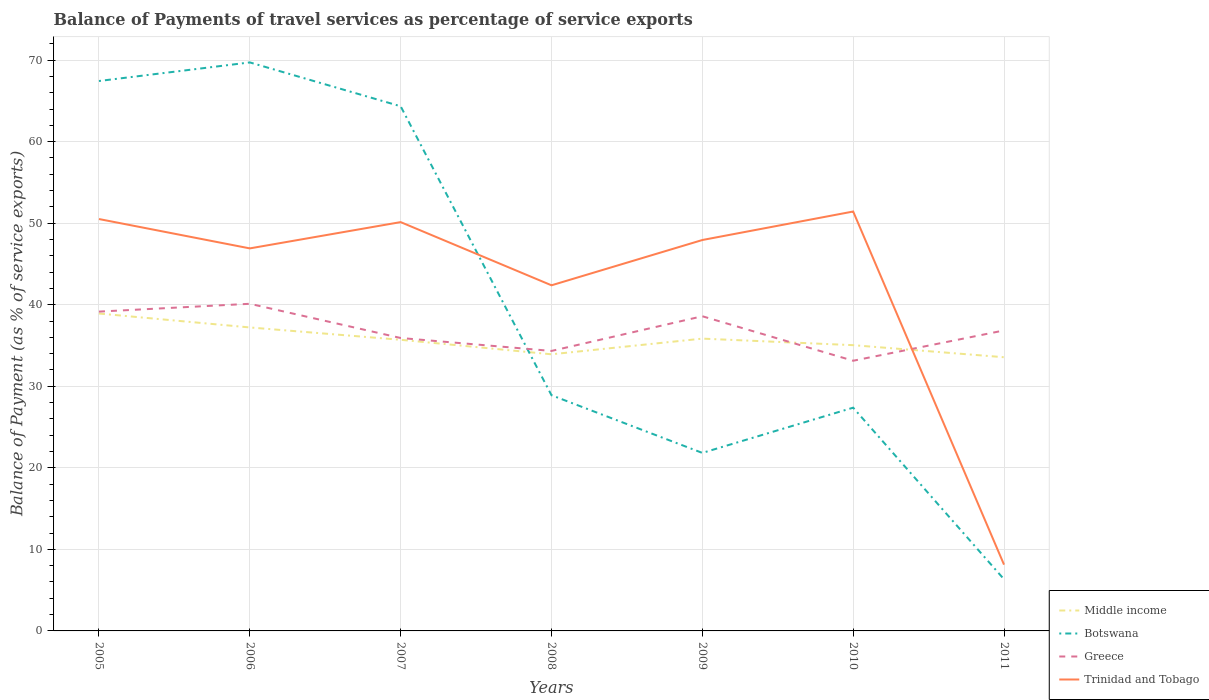Across all years, what is the maximum balance of payments of travel services in Middle income?
Your answer should be compact. 33.56. In which year was the balance of payments of travel services in Middle income maximum?
Keep it short and to the point. 2011. What is the total balance of payments of travel services in Middle income in the graph?
Offer a terse response. 3.08. What is the difference between the highest and the second highest balance of payments of travel services in Trinidad and Tobago?
Make the answer very short. 43.3. What is the difference between the highest and the lowest balance of payments of travel services in Trinidad and Tobago?
Provide a short and direct response. 5. How many lines are there?
Provide a succinct answer. 4. Does the graph contain grids?
Your response must be concise. Yes. How are the legend labels stacked?
Your answer should be very brief. Vertical. What is the title of the graph?
Offer a terse response. Balance of Payments of travel services as percentage of service exports. Does "Somalia" appear as one of the legend labels in the graph?
Give a very brief answer. No. What is the label or title of the X-axis?
Offer a very short reply. Years. What is the label or title of the Y-axis?
Give a very brief answer. Balance of Payment (as % of service exports). What is the Balance of Payment (as % of service exports) of Middle income in 2005?
Offer a very short reply. 38.92. What is the Balance of Payment (as % of service exports) in Botswana in 2005?
Give a very brief answer. 67.43. What is the Balance of Payment (as % of service exports) in Greece in 2005?
Offer a terse response. 39.16. What is the Balance of Payment (as % of service exports) of Trinidad and Tobago in 2005?
Give a very brief answer. 50.51. What is the Balance of Payment (as % of service exports) of Middle income in 2006?
Your answer should be compact. 37.21. What is the Balance of Payment (as % of service exports) in Botswana in 2006?
Provide a succinct answer. 69.71. What is the Balance of Payment (as % of service exports) of Greece in 2006?
Keep it short and to the point. 40.11. What is the Balance of Payment (as % of service exports) of Trinidad and Tobago in 2006?
Ensure brevity in your answer.  46.91. What is the Balance of Payment (as % of service exports) of Middle income in 2007?
Ensure brevity in your answer.  35.7. What is the Balance of Payment (as % of service exports) in Botswana in 2007?
Offer a terse response. 64.33. What is the Balance of Payment (as % of service exports) of Greece in 2007?
Keep it short and to the point. 35.92. What is the Balance of Payment (as % of service exports) in Trinidad and Tobago in 2007?
Offer a very short reply. 50.13. What is the Balance of Payment (as % of service exports) of Middle income in 2008?
Provide a short and direct response. 33.92. What is the Balance of Payment (as % of service exports) in Botswana in 2008?
Your answer should be compact. 28.9. What is the Balance of Payment (as % of service exports) of Greece in 2008?
Provide a succinct answer. 34.33. What is the Balance of Payment (as % of service exports) in Trinidad and Tobago in 2008?
Provide a short and direct response. 42.38. What is the Balance of Payment (as % of service exports) of Middle income in 2009?
Offer a very short reply. 35.84. What is the Balance of Payment (as % of service exports) of Botswana in 2009?
Your answer should be compact. 21.83. What is the Balance of Payment (as % of service exports) of Greece in 2009?
Provide a succinct answer. 38.59. What is the Balance of Payment (as % of service exports) in Trinidad and Tobago in 2009?
Offer a very short reply. 47.93. What is the Balance of Payment (as % of service exports) of Middle income in 2010?
Offer a very short reply. 35.04. What is the Balance of Payment (as % of service exports) of Botswana in 2010?
Provide a succinct answer. 27.38. What is the Balance of Payment (as % of service exports) of Greece in 2010?
Give a very brief answer. 33.13. What is the Balance of Payment (as % of service exports) of Trinidad and Tobago in 2010?
Make the answer very short. 51.43. What is the Balance of Payment (as % of service exports) of Middle income in 2011?
Offer a terse response. 33.56. What is the Balance of Payment (as % of service exports) of Botswana in 2011?
Your answer should be very brief. 6.33. What is the Balance of Payment (as % of service exports) of Greece in 2011?
Keep it short and to the point. 36.85. What is the Balance of Payment (as % of service exports) in Trinidad and Tobago in 2011?
Give a very brief answer. 8.13. Across all years, what is the maximum Balance of Payment (as % of service exports) of Middle income?
Keep it short and to the point. 38.92. Across all years, what is the maximum Balance of Payment (as % of service exports) of Botswana?
Give a very brief answer. 69.71. Across all years, what is the maximum Balance of Payment (as % of service exports) of Greece?
Your answer should be compact. 40.11. Across all years, what is the maximum Balance of Payment (as % of service exports) of Trinidad and Tobago?
Provide a short and direct response. 51.43. Across all years, what is the minimum Balance of Payment (as % of service exports) of Middle income?
Ensure brevity in your answer.  33.56. Across all years, what is the minimum Balance of Payment (as % of service exports) in Botswana?
Give a very brief answer. 6.33. Across all years, what is the minimum Balance of Payment (as % of service exports) in Greece?
Offer a terse response. 33.13. Across all years, what is the minimum Balance of Payment (as % of service exports) of Trinidad and Tobago?
Your response must be concise. 8.13. What is the total Balance of Payment (as % of service exports) of Middle income in the graph?
Provide a short and direct response. 250.2. What is the total Balance of Payment (as % of service exports) in Botswana in the graph?
Provide a succinct answer. 285.92. What is the total Balance of Payment (as % of service exports) of Greece in the graph?
Keep it short and to the point. 258.09. What is the total Balance of Payment (as % of service exports) of Trinidad and Tobago in the graph?
Offer a terse response. 297.42. What is the difference between the Balance of Payment (as % of service exports) of Middle income in 2005 and that in 2006?
Provide a short and direct response. 1.71. What is the difference between the Balance of Payment (as % of service exports) of Botswana in 2005 and that in 2006?
Make the answer very short. -2.28. What is the difference between the Balance of Payment (as % of service exports) in Greece in 2005 and that in 2006?
Provide a succinct answer. -0.96. What is the difference between the Balance of Payment (as % of service exports) in Trinidad and Tobago in 2005 and that in 2006?
Your answer should be compact. 3.6. What is the difference between the Balance of Payment (as % of service exports) of Middle income in 2005 and that in 2007?
Give a very brief answer. 3.22. What is the difference between the Balance of Payment (as % of service exports) of Botswana in 2005 and that in 2007?
Give a very brief answer. 3.1. What is the difference between the Balance of Payment (as % of service exports) of Greece in 2005 and that in 2007?
Your answer should be compact. 3.23. What is the difference between the Balance of Payment (as % of service exports) in Trinidad and Tobago in 2005 and that in 2007?
Provide a succinct answer. 0.38. What is the difference between the Balance of Payment (as % of service exports) of Middle income in 2005 and that in 2008?
Keep it short and to the point. 5. What is the difference between the Balance of Payment (as % of service exports) of Botswana in 2005 and that in 2008?
Keep it short and to the point. 38.53. What is the difference between the Balance of Payment (as % of service exports) in Greece in 2005 and that in 2008?
Ensure brevity in your answer.  4.82. What is the difference between the Balance of Payment (as % of service exports) in Trinidad and Tobago in 2005 and that in 2008?
Your answer should be compact. 8.13. What is the difference between the Balance of Payment (as % of service exports) in Middle income in 2005 and that in 2009?
Offer a terse response. 3.08. What is the difference between the Balance of Payment (as % of service exports) of Botswana in 2005 and that in 2009?
Ensure brevity in your answer.  45.6. What is the difference between the Balance of Payment (as % of service exports) of Greece in 2005 and that in 2009?
Keep it short and to the point. 0.57. What is the difference between the Balance of Payment (as % of service exports) of Trinidad and Tobago in 2005 and that in 2009?
Provide a short and direct response. 2.57. What is the difference between the Balance of Payment (as % of service exports) in Middle income in 2005 and that in 2010?
Give a very brief answer. 3.88. What is the difference between the Balance of Payment (as % of service exports) in Botswana in 2005 and that in 2010?
Offer a terse response. 40.06. What is the difference between the Balance of Payment (as % of service exports) in Greece in 2005 and that in 2010?
Keep it short and to the point. 6.02. What is the difference between the Balance of Payment (as % of service exports) of Trinidad and Tobago in 2005 and that in 2010?
Offer a terse response. -0.92. What is the difference between the Balance of Payment (as % of service exports) of Middle income in 2005 and that in 2011?
Provide a succinct answer. 5.36. What is the difference between the Balance of Payment (as % of service exports) of Botswana in 2005 and that in 2011?
Keep it short and to the point. 61.1. What is the difference between the Balance of Payment (as % of service exports) of Greece in 2005 and that in 2011?
Keep it short and to the point. 2.31. What is the difference between the Balance of Payment (as % of service exports) of Trinidad and Tobago in 2005 and that in 2011?
Provide a succinct answer. 42.38. What is the difference between the Balance of Payment (as % of service exports) of Middle income in 2006 and that in 2007?
Provide a succinct answer. 1.51. What is the difference between the Balance of Payment (as % of service exports) in Botswana in 2006 and that in 2007?
Ensure brevity in your answer.  5.38. What is the difference between the Balance of Payment (as % of service exports) of Greece in 2006 and that in 2007?
Make the answer very short. 4.19. What is the difference between the Balance of Payment (as % of service exports) in Trinidad and Tobago in 2006 and that in 2007?
Give a very brief answer. -3.22. What is the difference between the Balance of Payment (as % of service exports) in Middle income in 2006 and that in 2008?
Keep it short and to the point. 3.29. What is the difference between the Balance of Payment (as % of service exports) in Botswana in 2006 and that in 2008?
Ensure brevity in your answer.  40.81. What is the difference between the Balance of Payment (as % of service exports) of Greece in 2006 and that in 2008?
Ensure brevity in your answer.  5.78. What is the difference between the Balance of Payment (as % of service exports) in Trinidad and Tobago in 2006 and that in 2008?
Provide a short and direct response. 4.53. What is the difference between the Balance of Payment (as % of service exports) of Middle income in 2006 and that in 2009?
Your response must be concise. 1.37. What is the difference between the Balance of Payment (as % of service exports) of Botswana in 2006 and that in 2009?
Your answer should be very brief. 47.88. What is the difference between the Balance of Payment (as % of service exports) of Greece in 2006 and that in 2009?
Provide a short and direct response. 1.53. What is the difference between the Balance of Payment (as % of service exports) of Trinidad and Tobago in 2006 and that in 2009?
Your answer should be compact. -1.03. What is the difference between the Balance of Payment (as % of service exports) of Middle income in 2006 and that in 2010?
Your answer should be compact. 2.17. What is the difference between the Balance of Payment (as % of service exports) of Botswana in 2006 and that in 2010?
Provide a short and direct response. 42.34. What is the difference between the Balance of Payment (as % of service exports) in Greece in 2006 and that in 2010?
Ensure brevity in your answer.  6.98. What is the difference between the Balance of Payment (as % of service exports) of Trinidad and Tobago in 2006 and that in 2010?
Your answer should be very brief. -4.52. What is the difference between the Balance of Payment (as % of service exports) of Middle income in 2006 and that in 2011?
Make the answer very short. 3.65. What is the difference between the Balance of Payment (as % of service exports) of Botswana in 2006 and that in 2011?
Ensure brevity in your answer.  63.38. What is the difference between the Balance of Payment (as % of service exports) of Greece in 2006 and that in 2011?
Your answer should be very brief. 3.27. What is the difference between the Balance of Payment (as % of service exports) of Trinidad and Tobago in 2006 and that in 2011?
Give a very brief answer. 38.78. What is the difference between the Balance of Payment (as % of service exports) in Middle income in 2007 and that in 2008?
Make the answer very short. 1.78. What is the difference between the Balance of Payment (as % of service exports) of Botswana in 2007 and that in 2008?
Give a very brief answer. 35.43. What is the difference between the Balance of Payment (as % of service exports) in Greece in 2007 and that in 2008?
Your answer should be compact. 1.59. What is the difference between the Balance of Payment (as % of service exports) in Trinidad and Tobago in 2007 and that in 2008?
Your response must be concise. 7.75. What is the difference between the Balance of Payment (as % of service exports) in Middle income in 2007 and that in 2009?
Give a very brief answer. -0.14. What is the difference between the Balance of Payment (as % of service exports) in Botswana in 2007 and that in 2009?
Offer a terse response. 42.5. What is the difference between the Balance of Payment (as % of service exports) of Greece in 2007 and that in 2009?
Make the answer very short. -2.67. What is the difference between the Balance of Payment (as % of service exports) of Trinidad and Tobago in 2007 and that in 2009?
Give a very brief answer. 2.2. What is the difference between the Balance of Payment (as % of service exports) in Middle income in 2007 and that in 2010?
Provide a short and direct response. 0.66. What is the difference between the Balance of Payment (as % of service exports) of Botswana in 2007 and that in 2010?
Offer a terse response. 36.96. What is the difference between the Balance of Payment (as % of service exports) in Greece in 2007 and that in 2010?
Keep it short and to the point. 2.79. What is the difference between the Balance of Payment (as % of service exports) in Trinidad and Tobago in 2007 and that in 2010?
Your answer should be very brief. -1.3. What is the difference between the Balance of Payment (as % of service exports) of Middle income in 2007 and that in 2011?
Your response must be concise. 2.14. What is the difference between the Balance of Payment (as % of service exports) of Greece in 2007 and that in 2011?
Give a very brief answer. -0.93. What is the difference between the Balance of Payment (as % of service exports) of Trinidad and Tobago in 2007 and that in 2011?
Give a very brief answer. 42. What is the difference between the Balance of Payment (as % of service exports) in Middle income in 2008 and that in 2009?
Give a very brief answer. -1.92. What is the difference between the Balance of Payment (as % of service exports) in Botswana in 2008 and that in 2009?
Provide a short and direct response. 7.07. What is the difference between the Balance of Payment (as % of service exports) in Greece in 2008 and that in 2009?
Your answer should be compact. -4.25. What is the difference between the Balance of Payment (as % of service exports) in Trinidad and Tobago in 2008 and that in 2009?
Your answer should be very brief. -5.55. What is the difference between the Balance of Payment (as % of service exports) in Middle income in 2008 and that in 2010?
Provide a succinct answer. -1.12. What is the difference between the Balance of Payment (as % of service exports) of Botswana in 2008 and that in 2010?
Your response must be concise. 1.53. What is the difference between the Balance of Payment (as % of service exports) in Greece in 2008 and that in 2010?
Offer a very short reply. 1.2. What is the difference between the Balance of Payment (as % of service exports) in Trinidad and Tobago in 2008 and that in 2010?
Your answer should be compact. -9.05. What is the difference between the Balance of Payment (as % of service exports) of Middle income in 2008 and that in 2011?
Provide a short and direct response. 0.36. What is the difference between the Balance of Payment (as % of service exports) in Botswana in 2008 and that in 2011?
Offer a terse response. 22.57. What is the difference between the Balance of Payment (as % of service exports) in Greece in 2008 and that in 2011?
Ensure brevity in your answer.  -2.51. What is the difference between the Balance of Payment (as % of service exports) of Trinidad and Tobago in 2008 and that in 2011?
Provide a short and direct response. 34.25. What is the difference between the Balance of Payment (as % of service exports) of Middle income in 2009 and that in 2010?
Offer a terse response. 0.8. What is the difference between the Balance of Payment (as % of service exports) of Botswana in 2009 and that in 2010?
Your answer should be very brief. -5.55. What is the difference between the Balance of Payment (as % of service exports) of Greece in 2009 and that in 2010?
Offer a very short reply. 5.46. What is the difference between the Balance of Payment (as % of service exports) of Trinidad and Tobago in 2009 and that in 2010?
Keep it short and to the point. -3.5. What is the difference between the Balance of Payment (as % of service exports) of Middle income in 2009 and that in 2011?
Your answer should be compact. 2.28. What is the difference between the Balance of Payment (as % of service exports) of Botswana in 2009 and that in 2011?
Provide a short and direct response. 15.5. What is the difference between the Balance of Payment (as % of service exports) in Greece in 2009 and that in 2011?
Make the answer very short. 1.74. What is the difference between the Balance of Payment (as % of service exports) in Trinidad and Tobago in 2009 and that in 2011?
Give a very brief answer. 39.81. What is the difference between the Balance of Payment (as % of service exports) in Middle income in 2010 and that in 2011?
Your response must be concise. 1.48. What is the difference between the Balance of Payment (as % of service exports) of Botswana in 2010 and that in 2011?
Your answer should be very brief. 21.04. What is the difference between the Balance of Payment (as % of service exports) in Greece in 2010 and that in 2011?
Provide a succinct answer. -3.72. What is the difference between the Balance of Payment (as % of service exports) in Trinidad and Tobago in 2010 and that in 2011?
Give a very brief answer. 43.3. What is the difference between the Balance of Payment (as % of service exports) of Middle income in 2005 and the Balance of Payment (as % of service exports) of Botswana in 2006?
Make the answer very short. -30.79. What is the difference between the Balance of Payment (as % of service exports) of Middle income in 2005 and the Balance of Payment (as % of service exports) of Greece in 2006?
Your answer should be very brief. -1.19. What is the difference between the Balance of Payment (as % of service exports) of Middle income in 2005 and the Balance of Payment (as % of service exports) of Trinidad and Tobago in 2006?
Your response must be concise. -7.99. What is the difference between the Balance of Payment (as % of service exports) in Botswana in 2005 and the Balance of Payment (as % of service exports) in Greece in 2006?
Offer a very short reply. 27.32. What is the difference between the Balance of Payment (as % of service exports) of Botswana in 2005 and the Balance of Payment (as % of service exports) of Trinidad and Tobago in 2006?
Your response must be concise. 20.52. What is the difference between the Balance of Payment (as % of service exports) of Greece in 2005 and the Balance of Payment (as % of service exports) of Trinidad and Tobago in 2006?
Provide a short and direct response. -7.75. What is the difference between the Balance of Payment (as % of service exports) of Middle income in 2005 and the Balance of Payment (as % of service exports) of Botswana in 2007?
Ensure brevity in your answer.  -25.41. What is the difference between the Balance of Payment (as % of service exports) of Middle income in 2005 and the Balance of Payment (as % of service exports) of Greece in 2007?
Keep it short and to the point. 3. What is the difference between the Balance of Payment (as % of service exports) of Middle income in 2005 and the Balance of Payment (as % of service exports) of Trinidad and Tobago in 2007?
Ensure brevity in your answer.  -11.21. What is the difference between the Balance of Payment (as % of service exports) of Botswana in 2005 and the Balance of Payment (as % of service exports) of Greece in 2007?
Provide a succinct answer. 31.51. What is the difference between the Balance of Payment (as % of service exports) in Botswana in 2005 and the Balance of Payment (as % of service exports) in Trinidad and Tobago in 2007?
Offer a very short reply. 17.3. What is the difference between the Balance of Payment (as % of service exports) of Greece in 2005 and the Balance of Payment (as % of service exports) of Trinidad and Tobago in 2007?
Your answer should be compact. -10.97. What is the difference between the Balance of Payment (as % of service exports) of Middle income in 2005 and the Balance of Payment (as % of service exports) of Botswana in 2008?
Your response must be concise. 10.02. What is the difference between the Balance of Payment (as % of service exports) of Middle income in 2005 and the Balance of Payment (as % of service exports) of Greece in 2008?
Provide a succinct answer. 4.59. What is the difference between the Balance of Payment (as % of service exports) of Middle income in 2005 and the Balance of Payment (as % of service exports) of Trinidad and Tobago in 2008?
Ensure brevity in your answer.  -3.46. What is the difference between the Balance of Payment (as % of service exports) of Botswana in 2005 and the Balance of Payment (as % of service exports) of Greece in 2008?
Keep it short and to the point. 33.1. What is the difference between the Balance of Payment (as % of service exports) in Botswana in 2005 and the Balance of Payment (as % of service exports) in Trinidad and Tobago in 2008?
Make the answer very short. 25.05. What is the difference between the Balance of Payment (as % of service exports) in Greece in 2005 and the Balance of Payment (as % of service exports) in Trinidad and Tobago in 2008?
Offer a terse response. -3.23. What is the difference between the Balance of Payment (as % of service exports) of Middle income in 2005 and the Balance of Payment (as % of service exports) of Botswana in 2009?
Offer a terse response. 17.09. What is the difference between the Balance of Payment (as % of service exports) in Middle income in 2005 and the Balance of Payment (as % of service exports) in Greece in 2009?
Provide a succinct answer. 0.33. What is the difference between the Balance of Payment (as % of service exports) of Middle income in 2005 and the Balance of Payment (as % of service exports) of Trinidad and Tobago in 2009?
Offer a very short reply. -9.01. What is the difference between the Balance of Payment (as % of service exports) of Botswana in 2005 and the Balance of Payment (as % of service exports) of Greece in 2009?
Give a very brief answer. 28.85. What is the difference between the Balance of Payment (as % of service exports) of Botswana in 2005 and the Balance of Payment (as % of service exports) of Trinidad and Tobago in 2009?
Your answer should be compact. 19.5. What is the difference between the Balance of Payment (as % of service exports) in Greece in 2005 and the Balance of Payment (as % of service exports) in Trinidad and Tobago in 2009?
Keep it short and to the point. -8.78. What is the difference between the Balance of Payment (as % of service exports) of Middle income in 2005 and the Balance of Payment (as % of service exports) of Botswana in 2010?
Provide a short and direct response. 11.55. What is the difference between the Balance of Payment (as % of service exports) of Middle income in 2005 and the Balance of Payment (as % of service exports) of Greece in 2010?
Ensure brevity in your answer.  5.79. What is the difference between the Balance of Payment (as % of service exports) of Middle income in 2005 and the Balance of Payment (as % of service exports) of Trinidad and Tobago in 2010?
Provide a succinct answer. -12.51. What is the difference between the Balance of Payment (as % of service exports) in Botswana in 2005 and the Balance of Payment (as % of service exports) in Greece in 2010?
Ensure brevity in your answer.  34.3. What is the difference between the Balance of Payment (as % of service exports) in Botswana in 2005 and the Balance of Payment (as % of service exports) in Trinidad and Tobago in 2010?
Offer a terse response. 16. What is the difference between the Balance of Payment (as % of service exports) of Greece in 2005 and the Balance of Payment (as % of service exports) of Trinidad and Tobago in 2010?
Provide a succinct answer. -12.27. What is the difference between the Balance of Payment (as % of service exports) in Middle income in 2005 and the Balance of Payment (as % of service exports) in Botswana in 2011?
Your answer should be compact. 32.59. What is the difference between the Balance of Payment (as % of service exports) of Middle income in 2005 and the Balance of Payment (as % of service exports) of Greece in 2011?
Provide a short and direct response. 2.08. What is the difference between the Balance of Payment (as % of service exports) of Middle income in 2005 and the Balance of Payment (as % of service exports) of Trinidad and Tobago in 2011?
Ensure brevity in your answer.  30.79. What is the difference between the Balance of Payment (as % of service exports) of Botswana in 2005 and the Balance of Payment (as % of service exports) of Greece in 2011?
Give a very brief answer. 30.59. What is the difference between the Balance of Payment (as % of service exports) of Botswana in 2005 and the Balance of Payment (as % of service exports) of Trinidad and Tobago in 2011?
Provide a short and direct response. 59.3. What is the difference between the Balance of Payment (as % of service exports) in Greece in 2005 and the Balance of Payment (as % of service exports) in Trinidad and Tobago in 2011?
Your response must be concise. 31.03. What is the difference between the Balance of Payment (as % of service exports) in Middle income in 2006 and the Balance of Payment (as % of service exports) in Botswana in 2007?
Offer a very short reply. -27.12. What is the difference between the Balance of Payment (as % of service exports) in Middle income in 2006 and the Balance of Payment (as % of service exports) in Greece in 2007?
Your answer should be compact. 1.29. What is the difference between the Balance of Payment (as % of service exports) of Middle income in 2006 and the Balance of Payment (as % of service exports) of Trinidad and Tobago in 2007?
Ensure brevity in your answer.  -12.92. What is the difference between the Balance of Payment (as % of service exports) of Botswana in 2006 and the Balance of Payment (as % of service exports) of Greece in 2007?
Your answer should be compact. 33.79. What is the difference between the Balance of Payment (as % of service exports) of Botswana in 2006 and the Balance of Payment (as % of service exports) of Trinidad and Tobago in 2007?
Your answer should be very brief. 19.58. What is the difference between the Balance of Payment (as % of service exports) of Greece in 2006 and the Balance of Payment (as % of service exports) of Trinidad and Tobago in 2007?
Give a very brief answer. -10.02. What is the difference between the Balance of Payment (as % of service exports) in Middle income in 2006 and the Balance of Payment (as % of service exports) in Botswana in 2008?
Ensure brevity in your answer.  8.31. What is the difference between the Balance of Payment (as % of service exports) of Middle income in 2006 and the Balance of Payment (as % of service exports) of Greece in 2008?
Offer a terse response. 2.88. What is the difference between the Balance of Payment (as % of service exports) in Middle income in 2006 and the Balance of Payment (as % of service exports) in Trinidad and Tobago in 2008?
Make the answer very short. -5.17. What is the difference between the Balance of Payment (as % of service exports) of Botswana in 2006 and the Balance of Payment (as % of service exports) of Greece in 2008?
Your response must be concise. 35.38. What is the difference between the Balance of Payment (as % of service exports) of Botswana in 2006 and the Balance of Payment (as % of service exports) of Trinidad and Tobago in 2008?
Ensure brevity in your answer.  27.33. What is the difference between the Balance of Payment (as % of service exports) of Greece in 2006 and the Balance of Payment (as % of service exports) of Trinidad and Tobago in 2008?
Provide a succinct answer. -2.27. What is the difference between the Balance of Payment (as % of service exports) of Middle income in 2006 and the Balance of Payment (as % of service exports) of Botswana in 2009?
Keep it short and to the point. 15.38. What is the difference between the Balance of Payment (as % of service exports) in Middle income in 2006 and the Balance of Payment (as % of service exports) in Greece in 2009?
Your answer should be very brief. -1.37. What is the difference between the Balance of Payment (as % of service exports) of Middle income in 2006 and the Balance of Payment (as % of service exports) of Trinidad and Tobago in 2009?
Provide a short and direct response. -10.72. What is the difference between the Balance of Payment (as % of service exports) of Botswana in 2006 and the Balance of Payment (as % of service exports) of Greece in 2009?
Ensure brevity in your answer.  31.13. What is the difference between the Balance of Payment (as % of service exports) in Botswana in 2006 and the Balance of Payment (as % of service exports) in Trinidad and Tobago in 2009?
Your answer should be compact. 21.78. What is the difference between the Balance of Payment (as % of service exports) of Greece in 2006 and the Balance of Payment (as % of service exports) of Trinidad and Tobago in 2009?
Offer a very short reply. -7.82. What is the difference between the Balance of Payment (as % of service exports) of Middle income in 2006 and the Balance of Payment (as % of service exports) of Botswana in 2010?
Make the answer very short. 9.84. What is the difference between the Balance of Payment (as % of service exports) in Middle income in 2006 and the Balance of Payment (as % of service exports) in Greece in 2010?
Your answer should be compact. 4.08. What is the difference between the Balance of Payment (as % of service exports) of Middle income in 2006 and the Balance of Payment (as % of service exports) of Trinidad and Tobago in 2010?
Provide a short and direct response. -14.22. What is the difference between the Balance of Payment (as % of service exports) in Botswana in 2006 and the Balance of Payment (as % of service exports) in Greece in 2010?
Your answer should be compact. 36.58. What is the difference between the Balance of Payment (as % of service exports) in Botswana in 2006 and the Balance of Payment (as % of service exports) in Trinidad and Tobago in 2010?
Your answer should be very brief. 18.28. What is the difference between the Balance of Payment (as % of service exports) in Greece in 2006 and the Balance of Payment (as % of service exports) in Trinidad and Tobago in 2010?
Your response must be concise. -11.32. What is the difference between the Balance of Payment (as % of service exports) in Middle income in 2006 and the Balance of Payment (as % of service exports) in Botswana in 2011?
Your answer should be very brief. 30.88. What is the difference between the Balance of Payment (as % of service exports) of Middle income in 2006 and the Balance of Payment (as % of service exports) of Greece in 2011?
Offer a very short reply. 0.37. What is the difference between the Balance of Payment (as % of service exports) in Middle income in 2006 and the Balance of Payment (as % of service exports) in Trinidad and Tobago in 2011?
Provide a succinct answer. 29.09. What is the difference between the Balance of Payment (as % of service exports) of Botswana in 2006 and the Balance of Payment (as % of service exports) of Greece in 2011?
Your answer should be compact. 32.87. What is the difference between the Balance of Payment (as % of service exports) of Botswana in 2006 and the Balance of Payment (as % of service exports) of Trinidad and Tobago in 2011?
Your response must be concise. 61.59. What is the difference between the Balance of Payment (as % of service exports) in Greece in 2006 and the Balance of Payment (as % of service exports) in Trinidad and Tobago in 2011?
Ensure brevity in your answer.  31.99. What is the difference between the Balance of Payment (as % of service exports) of Middle income in 2007 and the Balance of Payment (as % of service exports) of Botswana in 2008?
Provide a short and direct response. 6.8. What is the difference between the Balance of Payment (as % of service exports) of Middle income in 2007 and the Balance of Payment (as % of service exports) of Greece in 2008?
Offer a terse response. 1.37. What is the difference between the Balance of Payment (as % of service exports) in Middle income in 2007 and the Balance of Payment (as % of service exports) in Trinidad and Tobago in 2008?
Ensure brevity in your answer.  -6.68. What is the difference between the Balance of Payment (as % of service exports) of Botswana in 2007 and the Balance of Payment (as % of service exports) of Greece in 2008?
Provide a short and direct response. 30. What is the difference between the Balance of Payment (as % of service exports) of Botswana in 2007 and the Balance of Payment (as % of service exports) of Trinidad and Tobago in 2008?
Provide a short and direct response. 21.95. What is the difference between the Balance of Payment (as % of service exports) in Greece in 2007 and the Balance of Payment (as % of service exports) in Trinidad and Tobago in 2008?
Make the answer very short. -6.46. What is the difference between the Balance of Payment (as % of service exports) of Middle income in 2007 and the Balance of Payment (as % of service exports) of Botswana in 2009?
Ensure brevity in your answer.  13.87. What is the difference between the Balance of Payment (as % of service exports) of Middle income in 2007 and the Balance of Payment (as % of service exports) of Greece in 2009?
Offer a very short reply. -2.89. What is the difference between the Balance of Payment (as % of service exports) of Middle income in 2007 and the Balance of Payment (as % of service exports) of Trinidad and Tobago in 2009?
Ensure brevity in your answer.  -12.23. What is the difference between the Balance of Payment (as % of service exports) in Botswana in 2007 and the Balance of Payment (as % of service exports) in Greece in 2009?
Your answer should be very brief. 25.75. What is the difference between the Balance of Payment (as % of service exports) in Botswana in 2007 and the Balance of Payment (as % of service exports) in Trinidad and Tobago in 2009?
Your answer should be very brief. 16.4. What is the difference between the Balance of Payment (as % of service exports) of Greece in 2007 and the Balance of Payment (as % of service exports) of Trinidad and Tobago in 2009?
Your answer should be compact. -12.01. What is the difference between the Balance of Payment (as % of service exports) of Middle income in 2007 and the Balance of Payment (as % of service exports) of Botswana in 2010?
Provide a succinct answer. 8.32. What is the difference between the Balance of Payment (as % of service exports) in Middle income in 2007 and the Balance of Payment (as % of service exports) in Greece in 2010?
Offer a terse response. 2.57. What is the difference between the Balance of Payment (as % of service exports) in Middle income in 2007 and the Balance of Payment (as % of service exports) in Trinidad and Tobago in 2010?
Your answer should be very brief. -15.73. What is the difference between the Balance of Payment (as % of service exports) of Botswana in 2007 and the Balance of Payment (as % of service exports) of Greece in 2010?
Ensure brevity in your answer.  31.2. What is the difference between the Balance of Payment (as % of service exports) in Botswana in 2007 and the Balance of Payment (as % of service exports) in Trinidad and Tobago in 2010?
Your response must be concise. 12.9. What is the difference between the Balance of Payment (as % of service exports) of Greece in 2007 and the Balance of Payment (as % of service exports) of Trinidad and Tobago in 2010?
Your response must be concise. -15.51. What is the difference between the Balance of Payment (as % of service exports) of Middle income in 2007 and the Balance of Payment (as % of service exports) of Botswana in 2011?
Keep it short and to the point. 29.37. What is the difference between the Balance of Payment (as % of service exports) of Middle income in 2007 and the Balance of Payment (as % of service exports) of Greece in 2011?
Your response must be concise. -1.15. What is the difference between the Balance of Payment (as % of service exports) of Middle income in 2007 and the Balance of Payment (as % of service exports) of Trinidad and Tobago in 2011?
Your answer should be very brief. 27.57. What is the difference between the Balance of Payment (as % of service exports) of Botswana in 2007 and the Balance of Payment (as % of service exports) of Greece in 2011?
Keep it short and to the point. 27.49. What is the difference between the Balance of Payment (as % of service exports) in Botswana in 2007 and the Balance of Payment (as % of service exports) in Trinidad and Tobago in 2011?
Provide a succinct answer. 56.21. What is the difference between the Balance of Payment (as % of service exports) in Greece in 2007 and the Balance of Payment (as % of service exports) in Trinidad and Tobago in 2011?
Ensure brevity in your answer.  27.79. What is the difference between the Balance of Payment (as % of service exports) of Middle income in 2008 and the Balance of Payment (as % of service exports) of Botswana in 2009?
Your answer should be compact. 12.09. What is the difference between the Balance of Payment (as % of service exports) of Middle income in 2008 and the Balance of Payment (as % of service exports) of Greece in 2009?
Offer a very short reply. -4.67. What is the difference between the Balance of Payment (as % of service exports) of Middle income in 2008 and the Balance of Payment (as % of service exports) of Trinidad and Tobago in 2009?
Make the answer very short. -14.01. What is the difference between the Balance of Payment (as % of service exports) of Botswana in 2008 and the Balance of Payment (as % of service exports) of Greece in 2009?
Ensure brevity in your answer.  -9.69. What is the difference between the Balance of Payment (as % of service exports) of Botswana in 2008 and the Balance of Payment (as % of service exports) of Trinidad and Tobago in 2009?
Your response must be concise. -19.03. What is the difference between the Balance of Payment (as % of service exports) in Greece in 2008 and the Balance of Payment (as % of service exports) in Trinidad and Tobago in 2009?
Your response must be concise. -13.6. What is the difference between the Balance of Payment (as % of service exports) of Middle income in 2008 and the Balance of Payment (as % of service exports) of Botswana in 2010?
Provide a succinct answer. 6.55. What is the difference between the Balance of Payment (as % of service exports) in Middle income in 2008 and the Balance of Payment (as % of service exports) in Greece in 2010?
Your answer should be very brief. 0.79. What is the difference between the Balance of Payment (as % of service exports) of Middle income in 2008 and the Balance of Payment (as % of service exports) of Trinidad and Tobago in 2010?
Provide a short and direct response. -17.51. What is the difference between the Balance of Payment (as % of service exports) of Botswana in 2008 and the Balance of Payment (as % of service exports) of Greece in 2010?
Provide a short and direct response. -4.23. What is the difference between the Balance of Payment (as % of service exports) in Botswana in 2008 and the Balance of Payment (as % of service exports) in Trinidad and Tobago in 2010?
Offer a terse response. -22.53. What is the difference between the Balance of Payment (as % of service exports) of Greece in 2008 and the Balance of Payment (as % of service exports) of Trinidad and Tobago in 2010?
Provide a succinct answer. -17.1. What is the difference between the Balance of Payment (as % of service exports) of Middle income in 2008 and the Balance of Payment (as % of service exports) of Botswana in 2011?
Make the answer very short. 27.59. What is the difference between the Balance of Payment (as % of service exports) in Middle income in 2008 and the Balance of Payment (as % of service exports) in Greece in 2011?
Offer a very short reply. -2.92. What is the difference between the Balance of Payment (as % of service exports) in Middle income in 2008 and the Balance of Payment (as % of service exports) in Trinidad and Tobago in 2011?
Your response must be concise. 25.79. What is the difference between the Balance of Payment (as % of service exports) in Botswana in 2008 and the Balance of Payment (as % of service exports) in Greece in 2011?
Keep it short and to the point. -7.95. What is the difference between the Balance of Payment (as % of service exports) of Botswana in 2008 and the Balance of Payment (as % of service exports) of Trinidad and Tobago in 2011?
Your answer should be compact. 20.77. What is the difference between the Balance of Payment (as % of service exports) of Greece in 2008 and the Balance of Payment (as % of service exports) of Trinidad and Tobago in 2011?
Keep it short and to the point. 26.21. What is the difference between the Balance of Payment (as % of service exports) in Middle income in 2009 and the Balance of Payment (as % of service exports) in Botswana in 2010?
Your response must be concise. 8.47. What is the difference between the Balance of Payment (as % of service exports) of Middle income in 2009 and the Balance of Payment (as % of service exports) of Greece in 2010?
Ensure brevity in your answer.  2.71. What is the difference between the Balance of Payment (as % of service exports) of Middle income in 2009 and the Balance of Payment (as % of service exports) of Trinidad and Tobago in 2010?
Provide a succinct answer. -15.59. What is the difference between the Balance of Payment (as % of service exports) of Botswana in 2009 and the Balance of Payment (as % of service exports) of Greece in 2010?
Provide a short and direct response. -11.3. What is the difference between the Balance of Payment (as % of service exports) in Botswana in 2009 and the Balance of Payment (as % of service exports) in Trinidad and Tobago in 2010?
Ensure brevity in your answer.  -29.6. What is the difference between the Balance of Payment (as % of service exports) in Greece in 2009 and the Balance of Payment (as % of service exports) in Trinidad and Tobago in 2010?
Offer a terse response. -12.84. What is the difference between the Balance of Payment (as % of service exports) of Middle income in 2009 and the Balance of Payment (as % of service exports) of Botswana in 2011?
Keep it short and to the point. 29.51. What is the difference between the Balance of Payment (as % of service exports) in Middle income in 2009 and the Balance of Payment (as % of service exports) in Greece in 2011?
Ensure brevity in your answer.  -1. What is the difference between the Balance of Payment (as % of service exports) of Middle income in 2009 and the Balance of Payment (as % of service exports) of Trinidad and Tobago in 2011?
Keep it short and to the point. 27.72. What is the difference between the Balance of Payment (as % of service exports) of Botswana in 2009 and the Balance of Payment (as % of service exports) of Greece in 2011?
Give a very brief answer. -15.02. What is the difference between the Balance of Payment (as % of service exports) of Botswana in 2009 and the Balance of Payment (as % of service exports) of Trinidad and Tobago in 2011?
Make the answer very short. 13.7. What is the difference between the Balance of Payment (as % of service exports) of Greece in 2009 and the Balance of Payment (as % of service exports) of Trinidad and Tobago in 2011?
Your answer should be very brief. 30.46. What is the difference between the Balance of Payment (as % of service exports) of Middle income in 2010 and the Balance of Payment (as % of service exports) of Botswana in 2011?
Offer a very short reply. 28.71. What is the difference between the Balance of Payment (as % of service exports) of Middle income in 2010 and the Balance of Payment (as % of service exports) of Greece in 2011?
Keep it short and to the point. -1.81. What is the difference between the Balance of Payment (as % of service exports) in Middle income in 2010 and the Balance of Payment (as % of service exports) in Trinidad and Tobago in 2011?
Your answer should be very brief. 26.91. What is the difference between the Balance of Payment (as % of service exports) of Botswana in 2010 and the Balance of Payment (as % of service exports) of Greece in 2011?
Your response must be concise. -9.47. What is the difference between the Balance of Payment (as % of service exports) in Botswana in 2010 and the Balance of Payment (as % of service exports) in Trinidad and Tobago in 2011?
Offer a very short reply. 19.25. What is the difference between the Balance of Payment (as % of service exports) in Greece in 2010 and the Balance of Payment (as % of service exports) in Trinidad and Tobago in 2011?
Provide a succinct answer. 25. What is the average Balance of Payment (as % of service exports) in Middle income per year?
Your answer should be very brief. 35.74. What is the average Balance of Payment (as % of service exports) in Botswana per year?
Your answer should be very brief. 40.85. What is the average Balance of Payment (as % of service exports) in Greece per year?
Keep it short and to the point. 36.87. What is the average Balance of Payment (as % of service exports) of Trinidad and Tobago per year?
Give a very brief answer. 42.49. In the year 2005, what is the difference between the Balance of Payment (as % of service exports) in Middle income and Balance of Payment (as % of service exports) in Botswana?
Your answer should be very brief. -28.51. In the year 2005, what is the difference between the Balance of Payment (as % of service exports) in Middle income and Balance of Payment (as % of service exports) in Greece?
Keep it short and to the point. -0.23. In the year 2005, what is the difference between the Balance of Payment (as % of service exports) in Middle income and Balance of Payment (as % of service exports) in Trinidad and Tobago?
Your answer should be very brief. -11.59. In the year 2005, what is the difference between the Balance of Payment (as % of service exports) in Botswana and Balance of Payment (as % of service exports) in Greece?
Give a very brief answer. 28.28. In the year 2005, what is the difference between the Balance of Payment (as % of service exports) of Botswana and Balance of Payment (as % of service exports) of Trinidad and Tobago?
Keep it short and to the point. 16.92. In the year 2005, what is the difference between the Balance of Payment (as % of service exports) of Greece and Balance of Payment (as % of service exports) of Trinidad and Tobago?
Your answer should be very brief. -11.35. In the year 2006, what is the difference between the Balance of Payment (as % of service exports) of Middle income and Balance of Payment (as % of service exports) of Botswana?
Offer a very short reply. -32.5. In the year 2006, what is the difference between the Balance of Payment (as % of service exports) of Middle income and Balance of Payment (as % of service exports) of Greece?
Provide a short and direct response. -2.9. In the year 2006, what is the difference between the Balance of Payment (as % of service exports) in Middle income and Balance of Payment (as % of service exports) in Trinidad and Tobago?
Make the answer very short. -9.69. In the year 2006, what is the difference between the Balance of Payment (as % of service exports) in Botswana and Balance of Payment (as % of service exports) in Greece?
Keep it short and to the point. 29.6. In the year 2006, what is the difference between the Balance of Payment (as % of service exports) of Botswana and Balance of Payment (as % of service exports) of Trinidad and Tobago?
Make the answer very short. 22.81. In the year 2006, what is the difference between the Balance of Payment (as % of service exports) in Greece and Balance of Payment (as % of service exports) in Trinidad and Tobago?
Your answer should be very brief. -6.79. In the year 2007, what is the difference between the Balance of Payment (as % of service exports) in Middle income and Balance of Payment (as % of service exports) in Botswana?
Keep it short and to the point. -28.63. In the year 2007, what is the difference between the Balance of Payment (as % of service exports) in Middle income and Balance of Payment (as % of service exports) in Greece?
Your answer should be very brief. -0.22. In the year 2007, what is the difference between the Balance of Payment (as % of service exports) in Middle income and Balance of Payment (as % of service exports) in Trinidad and Tobago?
Provide a succinct answer. -14.43. In the year 2007, what is the difference between the Balance of Payment (as % of service exports) of Botswana and Balance of Payment (as % of service exports) of Greece?
Give a very brief answer. 28.41. In the year 2007, what is the difference between the Balance of Payment (as % of service exports) in Botswana and Balance of Payment (as % of service exports) in Trinidad and Tobago?
Give a very brief answer. 14.2. In the year 2007, what is the difference between the Balance of Payment (as % of service exports) in Greece and Balance of Payment (as % of service exports) in Trinidad and Tobago?
Ensure brevity in your answer.  -14.21. In the year 2008, what is the difference between the Balance of Payment (as % of service exports) in Middle income and Balance of Payment (as % of service exports) in Botswana?
Make the answer very short. 5.02. In the year 2008, what is the difference between the Balance of Payment (as % of service exports) in Middle income and Balance of Payment (as % of service exports) in Greece?
Your answer should be very brief. -0.41. In the year 2008, what is the difference between the Balance of Payment (as % of service exports) in Middle income and Balance of Payment (as % of service exports) in Trinidad and Tobago?
Ensure brevity in your answer.  -8.46. In the year 2008, what is the difference between the Balance of Payment (as % of service exports) in Botswana and Balance of Payment (as % of service exports) in Greece?
Provide a succinct answer. -5.43. In the year 2008, what is the difference between the Balance of Payment (as % of service exports) in Botswana and Balance of Payment (as % of service exports) in Trinidad and Tobago?
Make the answer very short. -13.48. In the year 2008, what is the difference between the Balance of Payment (as % of service exports) of Greece and Balance of Payment (as % of service exports) of Trinidad and Tobago?
Provide a succinct answer. -8.05. In the year 2009, what is the difference between the Balance of Payment (as % of service exports) of Middle income and Balance of Payment (as % of service exports) of Botswana?
Your answer should be very brief. 14.01. In the year 2009, what is the difference between the Balance of Payment (as % of service exports) in Middle income and Balance of Payment (as % of service exports) in Greece?
Your answer should be very brief. -2.74. In the year 2009, what is the difference between the Balance of Payment (as % of service exports) of Middle income and Balance of Payment (as % of service exports) of Trinidad and Tobago?
Provide a short and direct response. -12.09. In the year 2009, what is the difference between the Balance of Payment (as % of service exports) in Botswana and Balance of Payment (as % of service exports) in Greece?
Give a very brief answer. -16.76. In the year 2009, what is the difference between the Balance of Payment (as % of service exports) of Botswana and Balance of Payment (as % of service exports) of Trinidad and Tobago?
Your answer should be very brief. -26.11. In the year 2009, what is the difference between the Balance of Payment (as % of service exports) in Greece and Balance of Payment (as % of service exports) in Trinidad and Tobago?
Offer a very short reply. -9.35. In the year 2010, what is the difference between the Balance of Payment (as % of service exports) in Middle income and Balance of Payment (as % of service exports) in Botswana?
Your answer should be compact. 7.66. In the year 2010, what is the difference between the Balance of Payment (as % of service exports) in Middle income and Balance of Payment (as % of service exports) in Greece?
Make the answer very short. 1.91. In the year 2010, what is the difference between the Balance of Payment (as % of service exports) in Middle income and Balance of Payment (as % of service exports) in Trinidad and Tobago?
Offer a very short reply. -16.39. In the year 2010, what is the difference between the Balance of Payment (as % of service exports) of Botswana and Balance of Payment (as % of service exports) of Greece?
Provide a short and direct response. -5.76. In the year 2010, what is the difference between the Balance of Payment (as % of service exports) in Botswana and Balance of Payment (as % of service exports) in Trinidad and Tobago?
Keep it short and to the point. -24.05. In the year 2010, what is the difference between the Balance of Payment (as % of service exports) of Greece and Balance of Payment (as % of service exports) of Trinidad and Tobago?
Give a very brief answer. -18.3. In the year 2011, what is the difference between the Balance of Payment (as % of service exports) in Middle income and Balance of Payment (as % of service exports) in Botswana?
Provide a short and direct response. 27.23. In the year 2011, what is the difference between the Balance of Payment (as % of service exports) of Middle income and Balance of Payment (as % of service exports) of Greece?
Provide a short and direct response. -3.29. In the year 2011, what is the difference between the Balance of Payment (as % of service exports) in Middle income and Balance of Payment (as % of service exports) in Trinidad and Tobago?
Provide a succinct answer. 25.43. In the year 2011, what is the difference between the Balance of Payment (as % of service exports) of Botswana and Balance of Payment (as % of service exports) of Greece?
Make the answer very short. -30.51. In the year 2011, what is the difference between the Balance of Payment (as % of service exports) in Botswana and Balance of Payment (as % of service exports) in Trinidad and Tobago?
Your answer should be very brief. -1.79. In the year 2011, what is the difference between the Balance of Payment (as % of service exports) in Greece and Balance of Payment (as % of service exports) in Trinidad and Tobago?
Your response must be concise. 28.72. What is the ratio of the Balance of Payment (as % of service exports) of Middle income in 2005 to that in 2006?
Ensure brevity in your answer.  1.05. What is the ratio of the Balance of Payment (as % of service exports) of Botswana in 2005 to that in 2006?
Keep it short and to the point. 0.97. What is the ratio of the Balance of Payment (as % of service exports) in Greece in 2005 to that in 2006?
Your response must be concise. 0.98. What is the ratio of the Balance of Payment (as % of service exports) of Trinidad and Tobago in 2005 to that in 2006?
Offer a terse response. 1.08. What is the ratio of the Balance of Payment (as % of service exports) in Middle income in 2005 to that in 2007?
Offer a terse response. 1.09. What is the ratio of the Balance of Payment (as % of service exports) in Botswana in 2005 to that in 2007?
Make the answer very short. 1.05. What is the ratio of the Balance of Payment (as % of service exports) in Greece in 2005 to that in 2007?
Make the answer very short. 1.09. What is the ratio of the Balance of Payment (as % of service exports) in Trinidad and Tobago in 2005 to that in 2007?
Your answer should be compact. 1.01. What is the ratio of the Balance of Payment (as % of service exports) in Middle income in 2005 to that in 2008?
Provide a short and direct response. 1.15. What is the ratio of the Balance of Payment (as % of service exports) of Botswana in 2005 to that in 2008?
Offer a very short reply. 2.33. What is the ratio of the Balance of Payment (as % of service exports) in Greece in 2005 to that in 2008?
Provide a succinct answer. 1.14. What is the ratio of the Balance of Payment (as % of service exports) of Trinidad and Tobago in 2005 to that in 2008?
Keep it short and to the point. 1.19. What is the ratio of the Balance of Payment (as % of service exports) of Middle income in 2005 to that in 2009?
Keep it short and to the point. 1.09. What is the ratio of the Balance of Payment (as % of service exports) in Botswana in 2005 to that in 2009?
Offer a terse response. 3.09. What is the ratio of the Balance of Payment (as % of service exports) of Greece in 2005 to that in 2009?
Your response must be concise. 1.01. What is the ratio of the Balance of Payment (as % of service exports) of Trinidad and Tobago in 2005 to that in 2009?
Offer a very short reply. 1.05. What is the ratio of the Balance of Payment (as % of service exports) in Middle income in 2005 to that in 2010?
Provide a short and direct response. 1.11. What is the ratio of the Balance of Payment (as % of service exports) in Botswana in 2005 to that in 2010?
Your answer should be very brief. 2.46. What is the ratio of the Balance of Payment (as % of service exports) in Greece in 2005 to that in 2010?
Offer a terse response. 1.18. What is the ratio of the Balance of Payment (as % of service exports) of Trinidad and Tobago in 2005 to that in 2010?
Provide a short and direct response. 0.98. What is the ratio of the Balance of Payment (as % of service exports) in Middle income in 2005 to that in 2011?
Your answer should be very brief. 1.16. What is the ratio of the Balance of Payment (as % of service exports) in Botswana in 2005 to that in 2011?
Keep it short and to the point. 10.65. What is the ratio of the Balance of Payment (as % of service exports) of Greece in 2005 to that in 2011?
Your response must be concise. 1.06. What is the ratio of the Balance of Payment (as % of service exports) in Trinidad and Tobago in 2005 to that in 2011?
Give a very brief answer. 6.21. What is the ratio of the Balance of Payment (as % of service exports) of Middle income in 2006 to that in 2007?
Ensure brevity in your answer.  1.04. What is the ratio of the Balance of Payment (as % of service exports) of Botswana in 2006 to that in 2007?
Provide a succinct answer. 1.08. What is the ratio of the Balance of Payment (as % of service exports) of Greece in 2006 to that in 2007?
Offer a terse response. 1.12. What is the ratio of the Balance of Payment (as % of service exports) in Trinidad and Tobago in 2006 to that in 2007?
Provide a short and direct response. 0.94. What is the ratio of the Balance of Payment (as % of service exports) in Middle income in 2006 to that in 2008?
Make the answer very short. 1.1. What is the ratio of the Balance of Payment (as % of service exports) of Botswana in 2006 to that in 2008?
Provide a succinct answer. 2.41. What is the ratio of the Balance of Payment (as % of service exports) of Greece in 2006 to that in 2008?
Give a very brief answer. 1.17. What is the ratio of the Balance of Payment (as % of service exports) in Trinidad and Tobago in 2006 to that in 2008?
Give a very brief answer. 1.11. What is the ratio of the Balance of Payment (as % of service exports) of Middle income in 2006 to that in 2009?
Provide a succinct answer. 1.04. What is the ratio of the Balance of Payment (as % of service exports) of Botswana in 2006 to that in 2009?
Provide a succinct answer. 3.19. What is the ratio of the Balance of Payment (as % of service exports) of Greece in 2006 to that in 2009?
Provide a succinct answer. 1.04. What is the ratio of the Balance of Payment (as % of service exports) in Trinidad and Tobago in 2006 to that in 2009?
Offer a terse response. 0.98. What is the ratio of the Balance of Payment (as % of service exports) in Middle income in 2006 to that in 2010?
Give a very brief answer. 1.06. What is the ratio of the Balance of Payment (as % of service exports) of Botswana in 2006 to that in 2010?
Give a very brief answer. 2.55. What is the ratio of the Balance of Payment (as % of service exports) of Greece in 2006 to that in 2010?
Your answer should be very brief. 1.21. What is the ratio of the Balance of Payment (as % of service exports) of Trinidad and Tobago in 2006 to that in 2010?
Keep it short and to the point. 0.91. What is the ratio of the Balance of Payment (as % of service exports) of Middle income in 2006 to that in 2011?
Your answer should be compact. 1.11. What is the ratio of the Balance of Payment (as % of service exports) of Botswana in 2006 to that in 2011?
Provide a succinct answer. 11.01. What is the ratio of the Balance of Payment (as % of service exports) in Greece in 2006 to that in 2011?
Give a very brief answer. 1.09. What is the ratio of the Balance of Payment (as % of service exports) of Trinidad and Tobago in 2006 to that in 2011?
Make the answer very short. 5.77. What is the ratio of the Balance of Payment (as % of service exports) in Middle income in 2007 to that in 2008?
Provide a succinct answer. 1.05. What is the ratio of the Balance of Payment (as % of service exports) of Botswana in 2007 to that in 2008?
Give a very brief answer. 2.23. What is the ratio of the Balance of Payment (as % of service exports) of Greece in 2007 to that in 2008?
Offer a very short reply. 1.05. What is the ratio of the Balance of Payment (as % of service exports) of Trinidad and Tobago in 2007 to that in 2008?
Your answer should be very brief. 1.18. What is the ratio of the Balance of Payment (as % of service exports) of Botswana in 2007 to that in 2009?
Make the answer very short. 2.95. What is the ratio of the Balance of Payment (as % of service exports) of Greece in 2007 to that in 2009?
Provide a short and direct response. 0.93. What is the ratio of the Balance of Payment (as % of service exports) in Trinidad and Tobago in 2007 to that in 2009?
Provide a short and direct response. 1.05. What is the ratio of the Balance of Payment (as % of service exports) of Middle income in 2007 to that in 2010?
Your response must be concise. 1.02. What is the ratio of the Balance of Payment (as % of service exports) in Botswana in 2007 to that in 2010?
Offer a terse response. 2.35. What is the ratio of the Balance of Payment (as % of service exports) in Greece in 2007 to that in 2010?
Offer a terse response. 1.08. What is the ratio of the Balance of Payment (as % of service exports) of Trinidad and Tobago in 2007 to that in 2010?
Ensure brevity in your answer.  0.97. What is the ratio of the Balance of Payment (as % of service exports) in Middle income in 2007 to that in 2011?
Keep it short and to the point. 1.06. What is the ratio of the Balance of Payment (as % of service exports) of Botswana in 2007 to that in 2011?
Keep it short and to the point. 10.16. What is the ratio of the Balance of Payment (as % of service exports) in Greece in 2007 to that in 2011?
Your answer should be compact. 0.97. What is the ratio of the Balance of Payment (as % of service exports) of Trinidad and Tobago in 2007 to that in 2011?
Make the answer very short. 6.17. What is the ratio of the Balance of Payment (as % of service exports) of Middle income in 2008 to that in 2009?
Your answer should be compact. 0.95. What is the ratio of the Balance of Payment (as % of service exports) of Botswana in 2008 to that in 2009?
Your response must be concise. 1.32. What is the ratio of the Balance of Payment (as % of service exports) of Greece in 2008 to that in 2009?
Your answer should be very brief. 0.89. What is the ratio of the Balance of Payment (as % of service exports) of Trinidad and Tobago in 2008 to that in 2009?
Provide a short and direct response. 0.88. What is the ratio of the Balance of Payment (as % of service exports) in Middle income in 2008 to that in 2010?
Your answer should be compact. 0.97. What is the ratio of the Balance of Payment (as % of service exports) in Botswana in 2008 to that in 2010?
Provide a short and direct response. 1.06. What is the ratio of the Balance of Payment (as % of service exports) of Greece in 2008 to that in 2010?
Give a very brief answer. 1.04. What is the ratio of the Balance of Payment (as % of service exports) of Trinidad and Tobago in 2008 to that in 2010?
Keep it short and to the point. 0.82. What is the ratio of the Balance of Payment (as % of service exports) of Middle income in 2008 to that in 2011?
Keep it short and to the point. 1.01. What is the ratio of the Balance of Payment (as % of service exports) of Botswana in 2008 to that in 2011?
Ensure brevity in your answer.  4.56. What is the ratio of the Balance of Payment (as % of service exports) in Greece in 2008 to that in 2011?
Give a very brief answer. 0.93. What is the ratio of the Balance of Payment (as % of service exports) of Trinidad and Tobago in 2008 to that in 2011?
Offer a terse response. 5.21. What is the ratio of the Balance of Payment (as % of service exports) of Middle income in 2009 to that in 2010?
Keep it short and to the point. 1.02. What is the ratio of the Balance of Payment (as % of service exports) in Botswana in 2009 to that in 2010?
Your answer should be very brief. 0.8. What is the ratio of the Balance of Payment (as % of service exports) in Greece in 2009 to that in 2010?
Offer a terse response. 1.16. What is the ratio of the Balance of Payment (as % of service exports) of Trinidad and Tobago in 2009 to that in 2010?
Provide a short and direct response. 0.93. What is the ratio of the Balance of Payment (as % of service exports) in Middle income in 2009 to that in 2011?
Provide a succinct answer. 1.07. What is the ratio of the Balance of Payment (as % of service exports) of Botswana in 2009 to that in 2011?
Give a very brief answer. 3.45. What is the ratio of the Balance of Payment (as % of service exports) in Greece in 2009 to that in 2011?
Offer a terse response. 1.05. What is the ratio of the Balance of Payment (as % of service exports) in Trinidad and Tobago in 2009 to that in 2011?
Your answer should be very brief. 5.9. What is the ratio of the Balance of Payment (as % of service exports) in Middle income in 2010 to that in 2011?
Make the answer very short. 1.04. What is the ratio of the Balance of Payment (as % of service exports) in Botswana in 2010 to that in 2011?
Your response must be concise. 4.32. What is the ratio of the Balance of Payment (as % of service exports) in Greece in 2010 to that in 2011?
Your response must be concise. 0.9. What is the ratio of the Balance of Payment (as % of service exports) in Trinidad and Tobago in 2010 to that in 2011?
Offer a terse response. 6.33. What is the difference between the highest and the second highest Balance of Payment (as % of service exports) of Middle income?
Provide a succinct answer. 1.71. What is the difference between the highest and the second highest Balance of Payment (as % of service exports) of Botswana?
Make the answer very short. 2.28. What is the difference between the highest and the second highest Balance of Payment (as % of service exports) in Greece?
Offer a very short reply. 0.96. What is the difference between the highest and the second highest Balance of Payment (as % of service exports) in Trinidad and Tobago?
Offer a terse response. 0.92. What is the difference between the highest and the lowest Balance of Payment (as % of service exports) of Middle income?
Your response must be concise. 5.36. What is the difference between the highest and the lowest Balance of Payment (as % of service exports) of Botswana?
Provide a short and direct response. 63.38. What is the difference between the highest and the lowest Balance of Payment (as % of service exports) in Greece?
Your response must be concise. 6.98. What is the difference between the highest and the lowest Balance of Payment (as % of service exports) of Trinidad and Tobago?
Offer a very short reply. 43.3. 